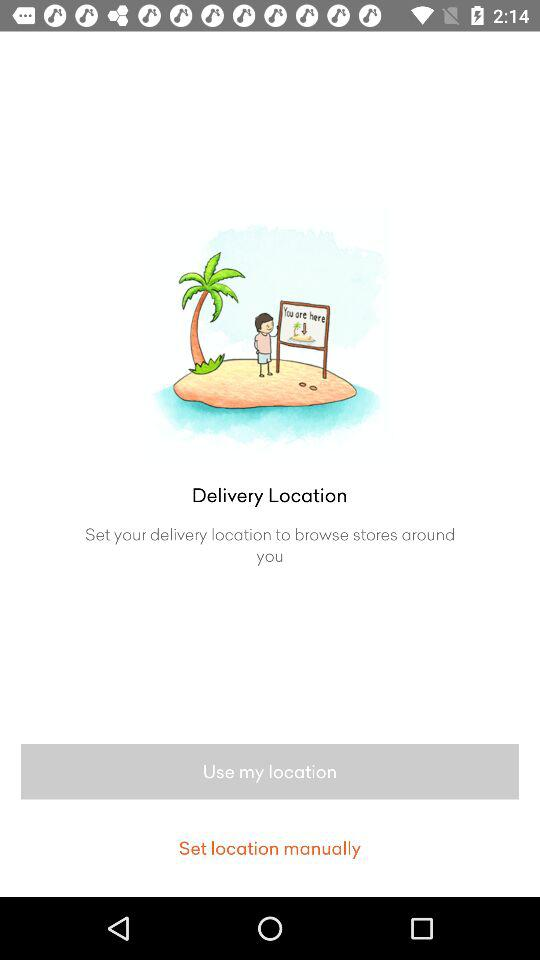Which option is selected?
When the provided information is insufficient, respond with <no answer>. <no answer> 